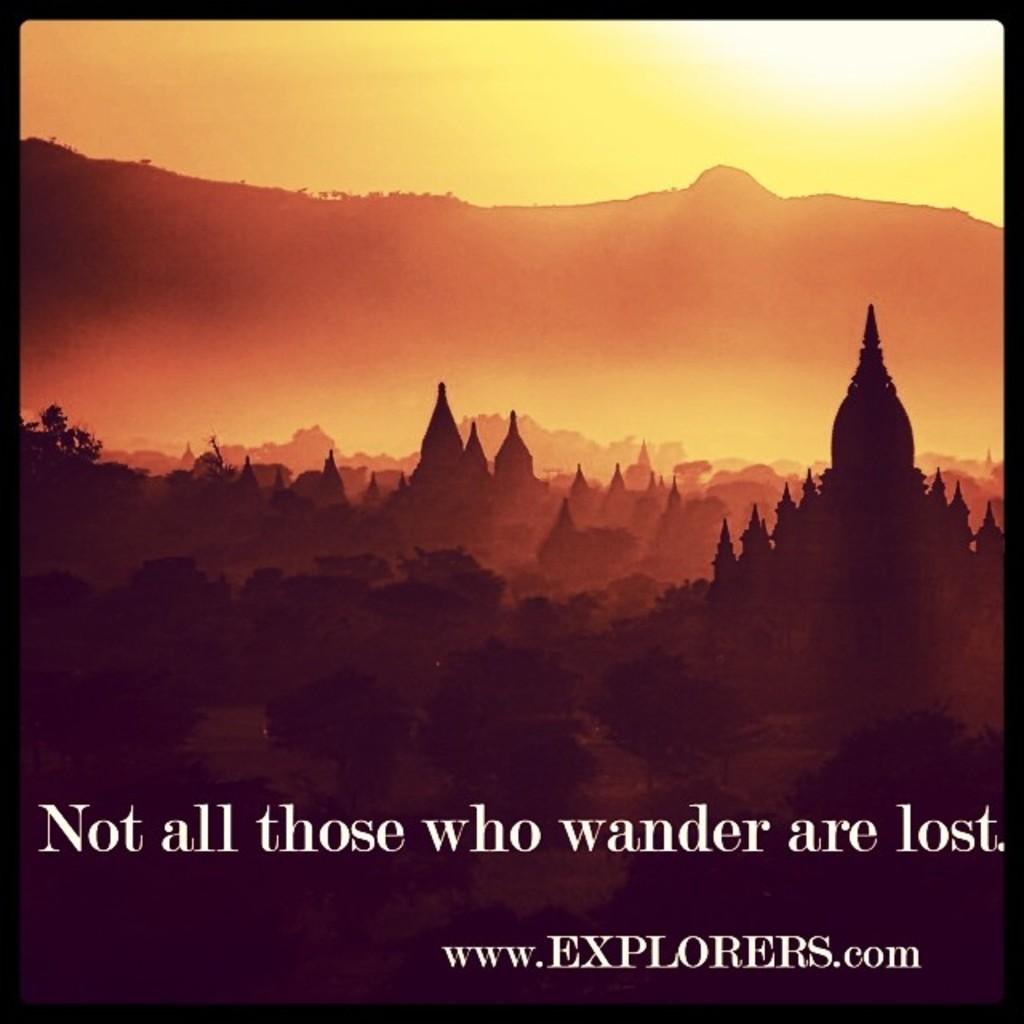What is the website?
Give a very brief answer. Www.explorers.com. What is the famous quote?
Your response must be concise. Not all those who wander are lost. 